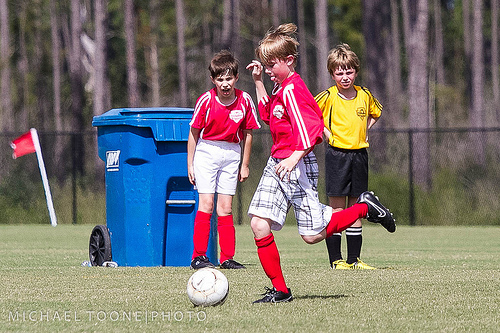<image>
Is there a garbage to the left of the flag? No. The garbage is not to the left of the flag. From this viewpoint, they have a different horizontal relationship. Where is the boy in relation to the box? Is it behind the box? No. The boy is not behind the box. From this viewpoint, the boy appears to be positioned elsewhere in the scene. Where is the bend in relation to the knee? Is it in the knee? Yes. The bend is contained within or inside the knee, showing a containment relationship. 